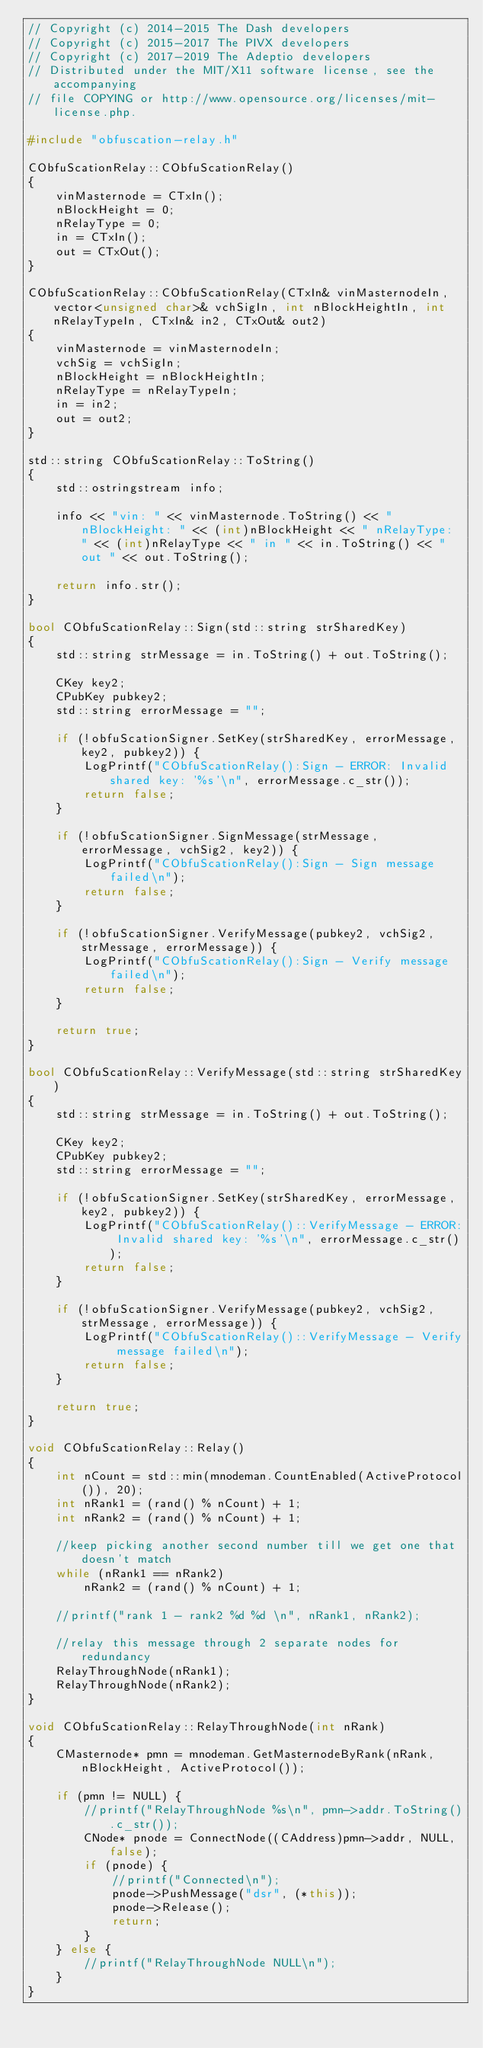<code> <loc_0><loc_0><loc_500><loc_500><_C++_>// Copyright (c) 2014-2015 The Dash developers
// Copyright (c) 2015-2017 The PIVX developers// Copyright (c) 2017-2019 The Adeptio developers
// Distributed under the MIT/X11 software license, see the accompanying
// file COPYING or http://www.opensource.org/licenses/mit-license.php.

#include "obfuscation-relay.h"

CObfuScationRelay::CObfuScationRelay()
{
    vinMasternode = CTxIn();
    nBlockHeight = 0;
    nRelayType = 0;
    in = CTxIn();
    out = CTxOut();
}

CObfuScationRelay::CObfuScationRelay(CTxIn& vinMasternodeIn, vector<unsigned char>& vchSigIn, int nBlockHeightIn, int nRelayTypeIn, CTxIn& in2, CTxOut& out2)
{
    vinMasternode = vinMasternodeIn;
    vchSig = vchSigIn;
    nBlockHeight = nBlockHeightIn;
    nRelayType = nRelayTypeIn;
    in = in2;
    out = out2;
}

std::string CObfuScationRelay::ToString()
{
    std::ostringstream info;

    info << "vin: " << vinMasternode.ToString() << " nBlockHeight: " << (int)nBlockHeight << " nRelayType: " << (int)nRelayType << " in " << in.ToString() << " out " << out.ToString();

    return info.str();
}

bool CObfuScationRelay::Sign(std::string strSharedKey)
{
    std::string strMessage = in.ToString() + out.ToString();

    CKey key2;
    CPubKey pubkey2;
    std::string errorMessage = "";

    if (!obfuScationSigner.SetKey(strSharedKey, errorMessage, key2, pubkey2)) {
        LogPrintf("CObfuScationRelay():Sign - ERROR: Invalid shared key: '%s'\n", errorMessage.c_str());
        return false;
    }

    if (!obfuScationSigner.SignMessage(strMessage, errorMessage, vchSig2, key2)) {
        LogPrintf("CObfuScationRelay():Sign - Sign message failed\n");
        return false;
    }

    if (!obfuScationSigner.VerifyMessage(pubkey2, vchSig2, strMessage, errorMessage)) {
        LogPrintf("CObfuScationRelay():Sign - Verify message failed\n");
        return false;
    }

    return true;
}

bool CObfuScationRelay::VerifyMessage(std::string strSharedKey)
{
    std::string strMessage = in.ToString() + out.ToString();

    CKey key2;
    CPubKey pubkey2;
    std::string errorMessage = "";

    if (!obfuScationSigner.SetKey(strSharedKey, errorMessage, key2, pubkey2)) {
        LogPrintf("CObfuScationRelay()::VerifyMessage - ERROR: Invalid shared key: '%s'\n", errorMessage.c_str());
        return false;
    }

    if (!obfuScationSigner.VerifyMessage(pubkey2, vchSig2, strMessage, errorMessage)) {
        LogPrintf("CObfuScationRelay()::VerifyMessage - Verify message failed\n");
        return false;
    }

    return true;
}

void CObfuScationRelay::Relay()
{
    int nCount = std::min(mnodeman.CountEnabled(ActiveProtocol()), 20);
    int nRank1 = (rand() % nCount) + 1;
    int nRank2 = (rand() % nCount) + 1;

    //keep picking another second number till we get one that doesn't match
    while (nRank1 == nRank2)
        nRank2 = (rand() % nCount) + 1;

    //printf("rank 1 - rank2 %d %d \n", nRank1, nRank2);

    //relay this message through 2 separate nodes for redundancy
    RelayThroughNode(nRank1);
    RelayThroughNode(nRank2);
}

void CObfuScationRelay::RelayThroughNode(int nRank)
{
    CMasternode* pmn = mnodeman.GetMasternodeByRank(nRank, nBlockHeight, ActiveProtocol());

    if (pmn != NULL) {
        //printf("RelayThroughNode %s\n", pmn->addr.ToString().c_str());
        CNode* pnode = ConnectNode((CAddress)pmn->addr, NULL, false);
        if (pnode) {
            //printf("Connected\n");
            pnode->PushMessage("dsr", (*this));
            pnode->Release();
            return;
        }
    } else {
        //printf("RelayThroughNode NULL\n");
    }
}
</code> 